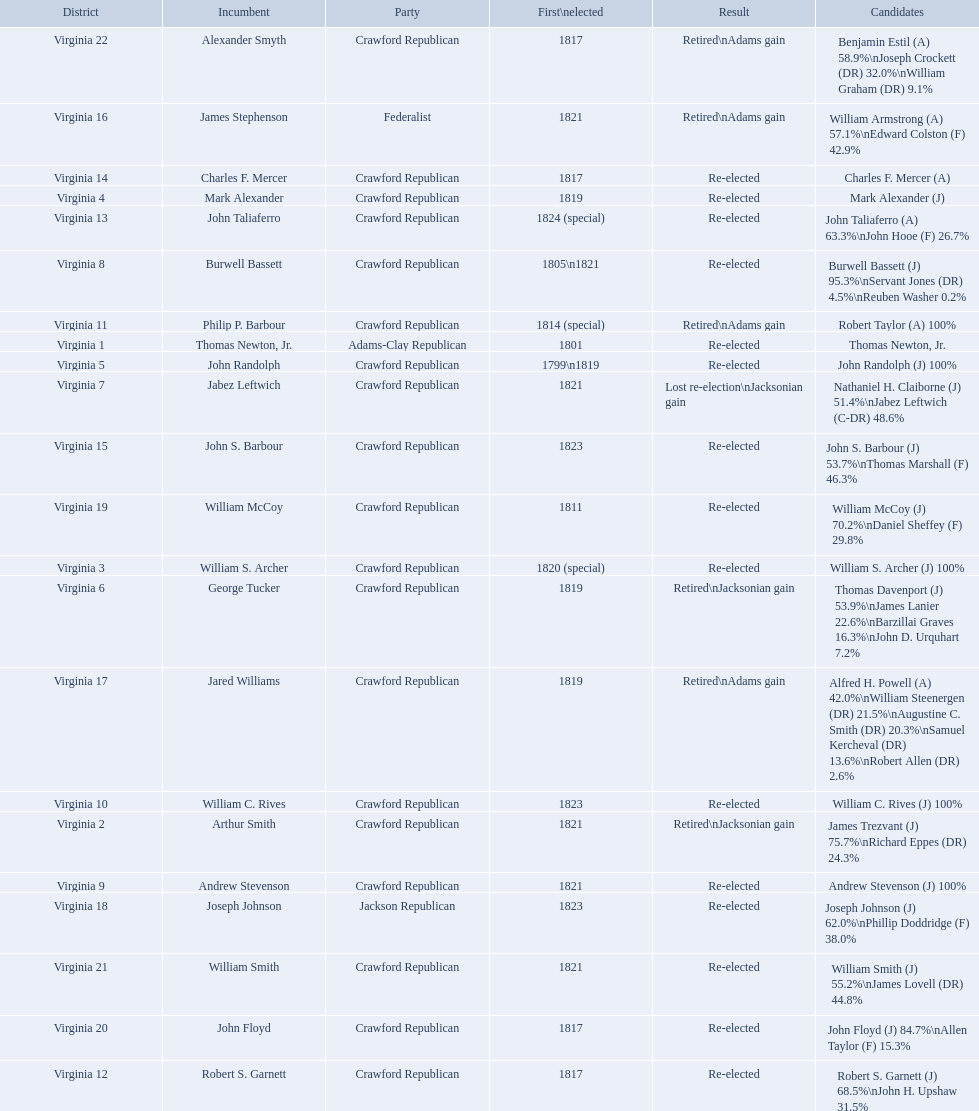What party is a crawford republican? Crawford Republican, Crawford Republican, Crawford Republican, Crawford Republican, Crawford Republican, Crawford Republican, Crawford Republican, Crawford Republican, Crawford Republican, Crawford Republican, Crawford Republican, Crawford Republican, Crawford Republican, Crawford Republican, Crawford Republican, Crawford Republican, Crawford Republican, Crawford Republican, Crawford Republican. What candidates have over 76%? James Trezvant (J) 75.7%\nRichard Eppes (DR) 24.3%, William S. Archer (J) 100%, John Randolph (J) 100%, Burwell Bassett (J) 95.3%\nServant Jones (DR) 4.5%\nReuben Washer 0.2%, Andrew Stevenson (J) 100%, William C. Rives (J) 100%, Robert Taylor (A) 100%, John Floyd (J) 84.7%\nAllen Taylor (F) 15.3%. Which result was retired jacksonian gain? Retired\nJacksonian gain. Who was the incumbent? Arthur Smith. 